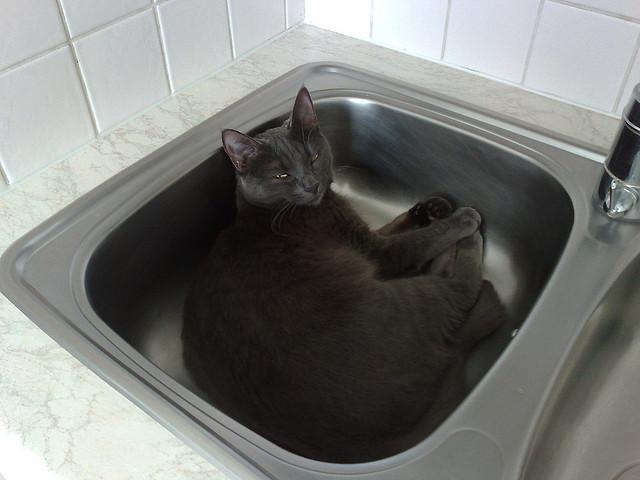How many people are wearing an ascot?
Give a very brief answer. 0. 